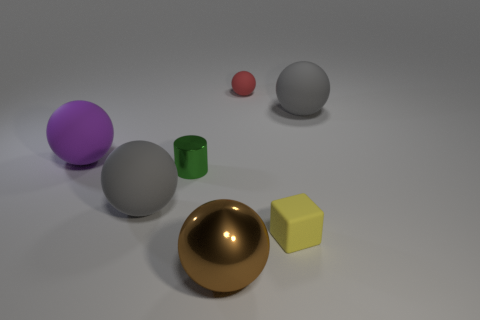How many cubes are either small blue rubber things or gray matte things?
Ensure brevity in your answer.  0. There is a ball that is both in front of the purple matte sphere and behind the matte cube; how big is it?
Ensure brevity in your answer.  Large. What number of other objects are there of the same color as the large metallic sphere?
Offer a very short reply. 0. Is the material of the big purple object the same as the tiny thing on the left side of the large shiny sphere?
Ensure brevity in your answer.  No. What number of things are either metal objects that are to the right of the green object or large blue spheres?
Your answer should be compact. 1. There is a large thing that is both in front of the large purple thing and behind the brown metallic object; what shape is it?
Offer a terse response. Sphere. The purple thing that is the same material as the tiny ball is what size?
Give a very brief answer. Large. What number of objects are rubber spheres that are left of the tiny green cylinder or rubber things on the right side of the small red matte ball?
Your answer should be compact. 4. There is a gray rubber sphere that is in front of the purple rubber thing; does it have the same size as the purple ball?
Make the answer very short. Yes. The rubber sphere that is right of the tiny yellow thing is what color?
Give a very brief answer. Gray. 